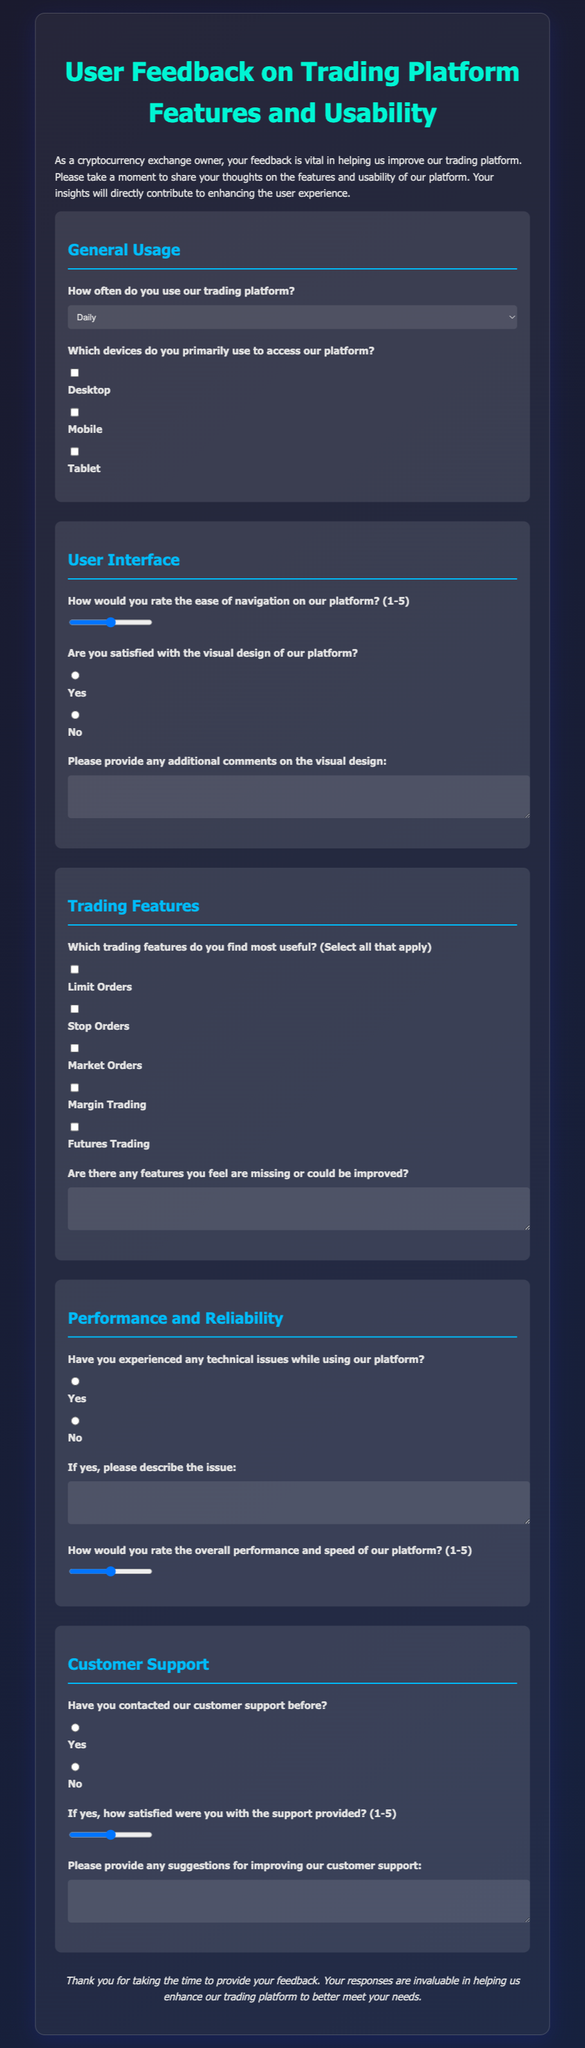How often do users primarily use the trading platform? The document includes a question with predefined options regarding the frequency of platform usage.
Answer: Daily, Weekly, Monthly, Occasionally What rating scale is used to assess the ease of navigation on the platform? The document specifies a rating scale for navigation ease from 1 to 5.
Answer: 1-5 What feature options are available for users to select in the trading features section? The document lists multiple trading features that users can find useful.
Answer: Limit Orders, Stop Orders, Market Orders, Margin Trading, Futures Trading What is asked regarding technical issues in the Performance and Reliability section? The document contains a question about whether users have encountered technical problems while using the platform.
Answer: Yes, No What type of feedback is requested regarding the visual design? The document includes a question asking for additional comments on the visual design of the platform.
Answer: Any additional comments What is stated about customer support contact? The document inquires if users have previously contacted customer support.
Answer: Yes, No 